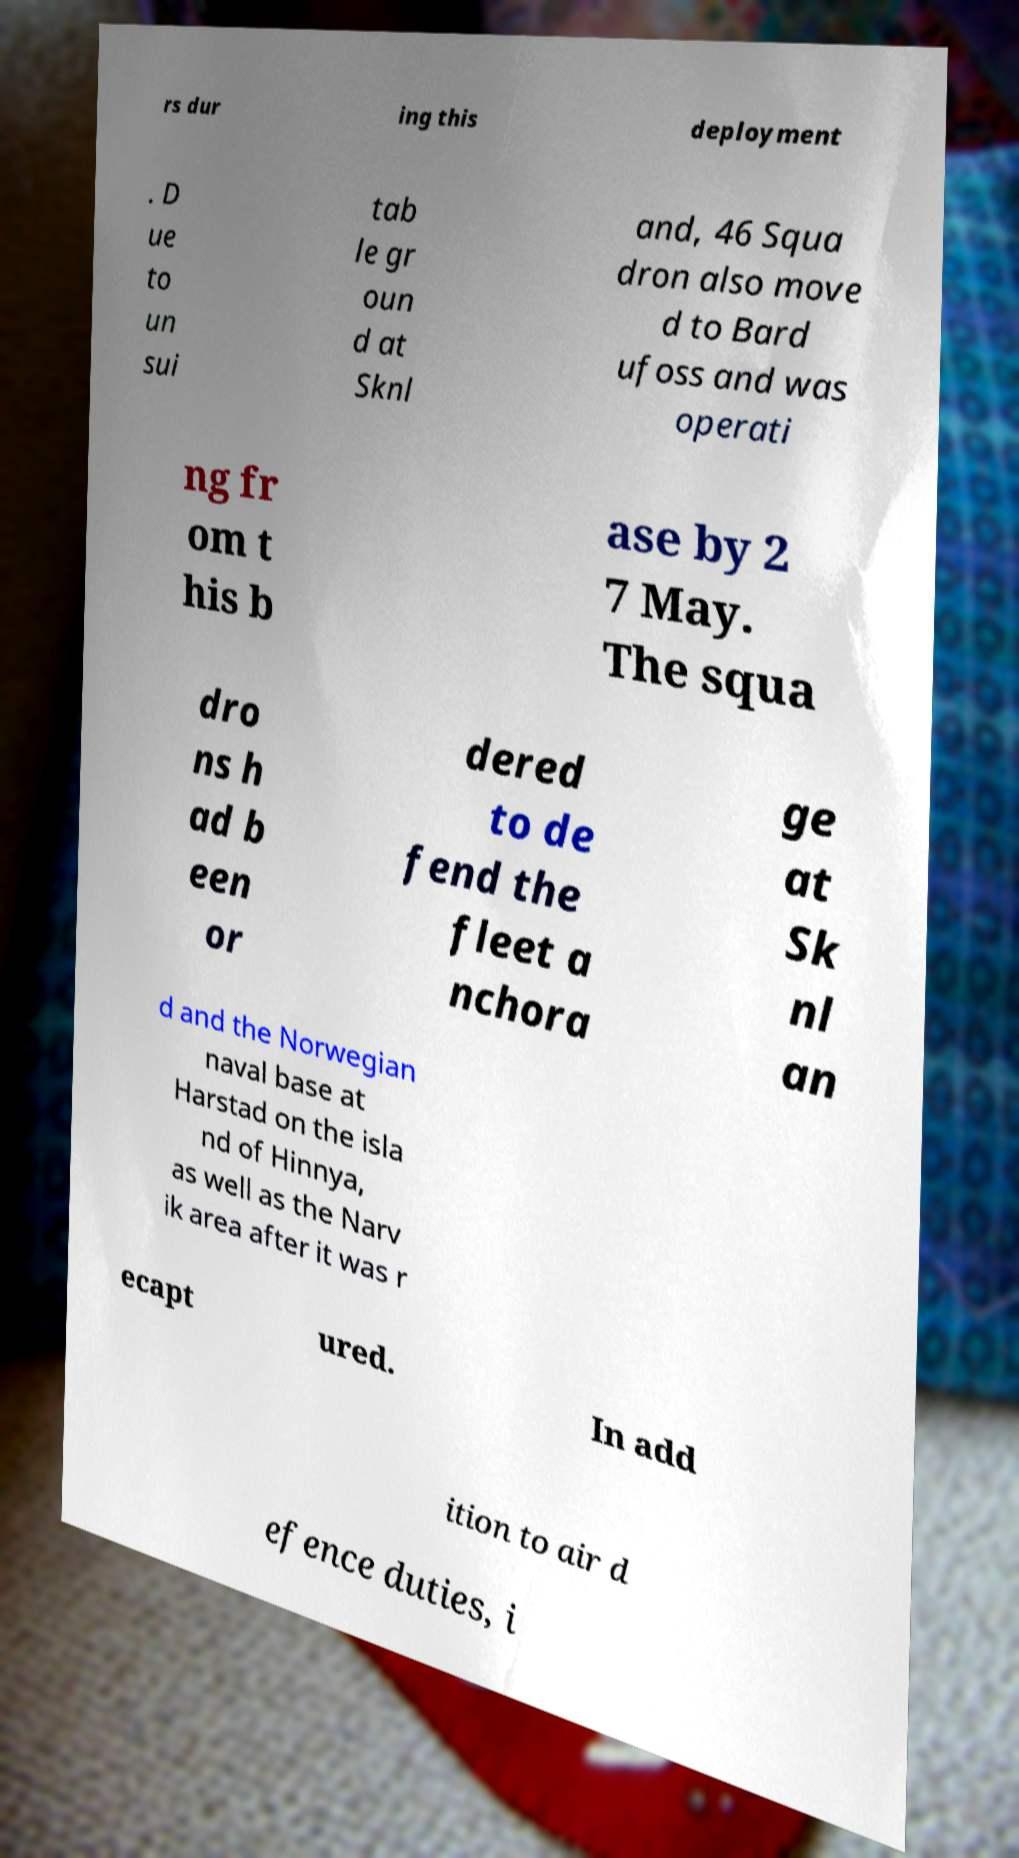Please read and relay the text visible in this image. What does it say? rs dur ing this deployment . D ue to un sui tab le gr oun d at Sknl and, 46 Squa dron also move d to Bard ufoss and was operati ng fr om t his b ase by 2 7 May. The squa dro ns h ad b een or dered to de fend the fleet a nchora ge at Sk nl an d and the Norwegian naval base at Harstad on the isla nd of Hinnya, as well as the Narv ik area after it was r ecapt ured. In add ition to air d efence duties, i 